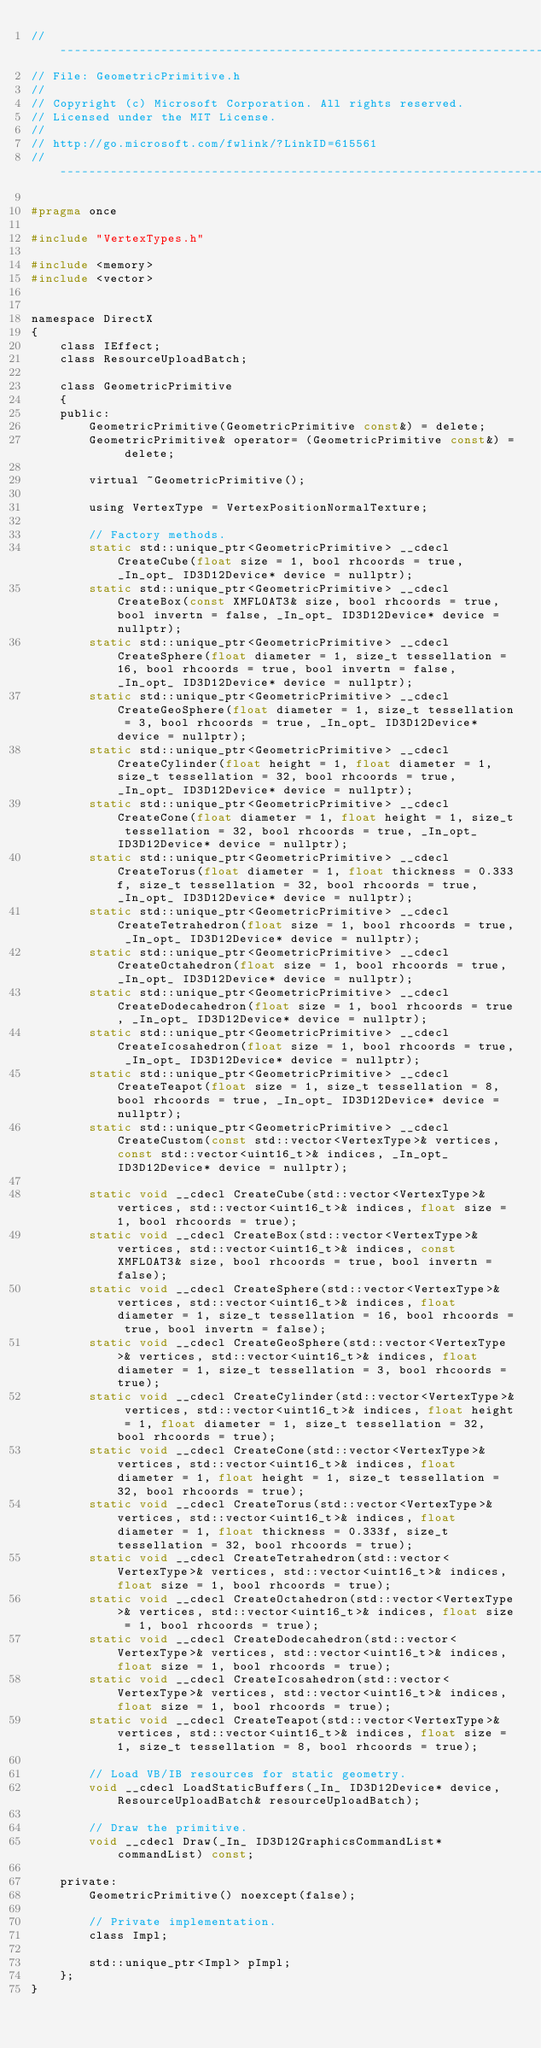Convert code to text. <code><loc_0><loc_0><loc_500><loc_500><_C_>//--------------------------------------------------------------------------------------
// File: GeometricPrimitive.h
//
// Copyright (c) Microsoft Corporation. All rights reserved.
// Licensed under the MIT License.
//
// http://go.microsoft.com/fwlink/?LinkID=615561
//--------------------------------------------------------------------------------------

#pragma once

#include "VertexTypes.h"

#include <memory>
#include <vector>


namespace DirectX
{
    class IEffect;
    class ResourceUploadBatch;

    class GeometricPrimitive
    {
    public:
        GeometricPrimitive(GeometricPrimitive const&) = delete;
        GeometricPrimitive& operator= (GeometricPrimitive const&) = delete;

        virtual ~GeometricPrimitive();

        using VertexType = VertexPositionNormalTexture;

        // Factory methods.
        static std::unique_ptr<GeometricPrimitive> __cdecl CreateCube(float size = 1, bool rhcoords = true, _In_opt_ ID3D12Device* device = nullptr);
        static std::unique_ptr<GeometricPrimitive> __cdecl CreateBox(const XMFLOAT3& size, bool rhcoords = true, bool invertn = false, _In_opt_ ID3D12Device* device = nullptr);
        static std::unique_ptr<GeometricPrimitive> __cdecl CreateSphere(float diameter = 1, size_t tessellation = 16, bool rhcoords = true, bool invertn = false, _In_opt_ ID3D12Device* device = nullptr);
        static std::unique_ptr<GeometricPrimitive> __cdecl CreateGeoSphere(float diameter = 1, size_t tessellation = 3, bool rhcoords = true, _In_opt_ ID3D12Device* device = nullptr);
        static std::unique_ptr<GeometricPrimitive> __cdecl CreateCylinder(float height = 1, float diameter = 1, size_t tessellation = 32, bool rhcoords = true, _In_opt_ ID3D12Device* device = nullptr);
        static std::unique_ptr<GeometricPrimitive> __cdecl CreateCone(float diameter = 1, float height = 1, size_t tessellation = 32, bool rhcoords = true, _In_opt_ ID3D12Device* device = nullptr);
        static std::unique_ptr<GeometricPrimitive> __cdecl CreateTorus(float diameter = 1, float thickness = 0.333f, size_t tessellation = 32, bool rhcoords = true, _In_opt_ ID3D12Device* device = nullptr);
        static std::unique_ptr<GeometricPrimitive> __cdecl CreateTetrahedron(float size = 1, bool rhcoords = true, _In_opt_ ID3D12Device* device = nullptr);
        static std::unique_ptr<GeometricPrimitive> __cdecl CreateOctahedron(float size = 1, bool rhcoords = true, _In_opt_ ID3D12Device* device = nullptr);
        static std::unique_ptr<GeometricPrimitive> __cdecl CreateDodecahedron(float size = 1, bool rhcoords = true, _In_opt_ ID3D12Device* device = nullptr);
        static std::unique_ptr<GeometricPrimitive> __cdecl CreateIcosahedron(float size = 1, bool rhcoords = true, _In_opt_ ID3D12Device* device = nullptr);
        static std::unique_ptr<GeometricPrimitive> __cdecl CreateTeapot(float size = 1, size_t tessellation = 8, bool rhcoords = true, _In_opt_ ID3D12Device* device = nullptr);
        static std::unique_ptr<GeometricPrimitive> __cdecl CreateCustom(const std::vector<VertexType>& vertices, const std::vector<uint16_t>& indices, _In_opt_ ID3D12Device* device = nullptr);

        static void __cdecl CreateCube(std::vector<VertexType>& vertices, std::vector<uint16_t>& indices, float size = 1, bool rhcoords = true);
        static void __cdecl CreateBox(std::vector<VertexType>& vertices, std::vector<uint16_t>& indices, const XMFLOAT3& size, bool rhcoords = true, bool invertn = false);
        static void __cdecl CreateSphere(std::vector<VertexType>& vertices, std::vector<uint16_t>& indices, float diameter = 1, size_t tessellation = 16, bool rhcoords = true, bool invertn = false);
        static void __cdecl CreateGeoSphere(std::vector<VertexType>& vertices, std::vector<uint16_t>& indices, float diameter = 1, size_t tessellation = 3, bool rhcoords = true);
        static void __cdecl CreateCylinder(std::vector<VertexType>& vertices, std::vector<uint16_t>& indices, float height = 1, float diameter = 1, size_t tessellation = 32, bool rhcoords = true);
        static void __cdecl CreateCone(std::vector<VertexType>& vertices, std::vector<uint16_t>& indices, float diameter = 1, float height = 1, size_t tessellation = 32, bool rhcoords = true);
        static void __cdecl CreateTorus(std::vector<VertexType>& vertices, std::vector<uint16_t>& indices, float diameter = 1, float thickness = 0.333f, size_t tessellation = 32, bool rhcoords = true);
        static void __cdecl CreateTetrahedron(std::vector<VertexType>& vertices, std::vector<uint16_t>& indices, float size = 1, bool rhcoords = true);
        static void __cdecl CreateOctahedron(std::vector<VertexType>& vertices, std::vector<uint16_t>& indices, float size = 1, bool rhcoords = true);
        static void __cdecl CreateDodecahedron(std::vector<VertexType>& vertices, std::vector<uint16_t>& indices, float size = 1, bool rhcoords = true);
        static void __cdecl CreateIcosahedron(std::vector<VertexType>& vertices, std::vector<uint16_t>& indices, float size = 1, bool rhcoords = true);
        static void __cdecl CreateTeapot(std::vector<VertexType>& vertices, std::vector<uint16_t>& indices, float size = 1, size_t tessellation = 8, bool rhcoords = true);

        // Load VB/IB resources for static geometry.
        void __cdecl LoadStaticBuffers(_In_ ID3D12Device* device, ResourceUploadBatch& resourceUploadBatch);

        // Draw the primitive.
        void __cdecl Draw(_In_ ID3D12GraphicsCommandList* commandList) const;

    private:
        GeometricPrimitive() noexcept(false);

        // Private implementation.
        class Impl;

        std::unique_ptr<Impl> pImpl;
    };
}
</code> 